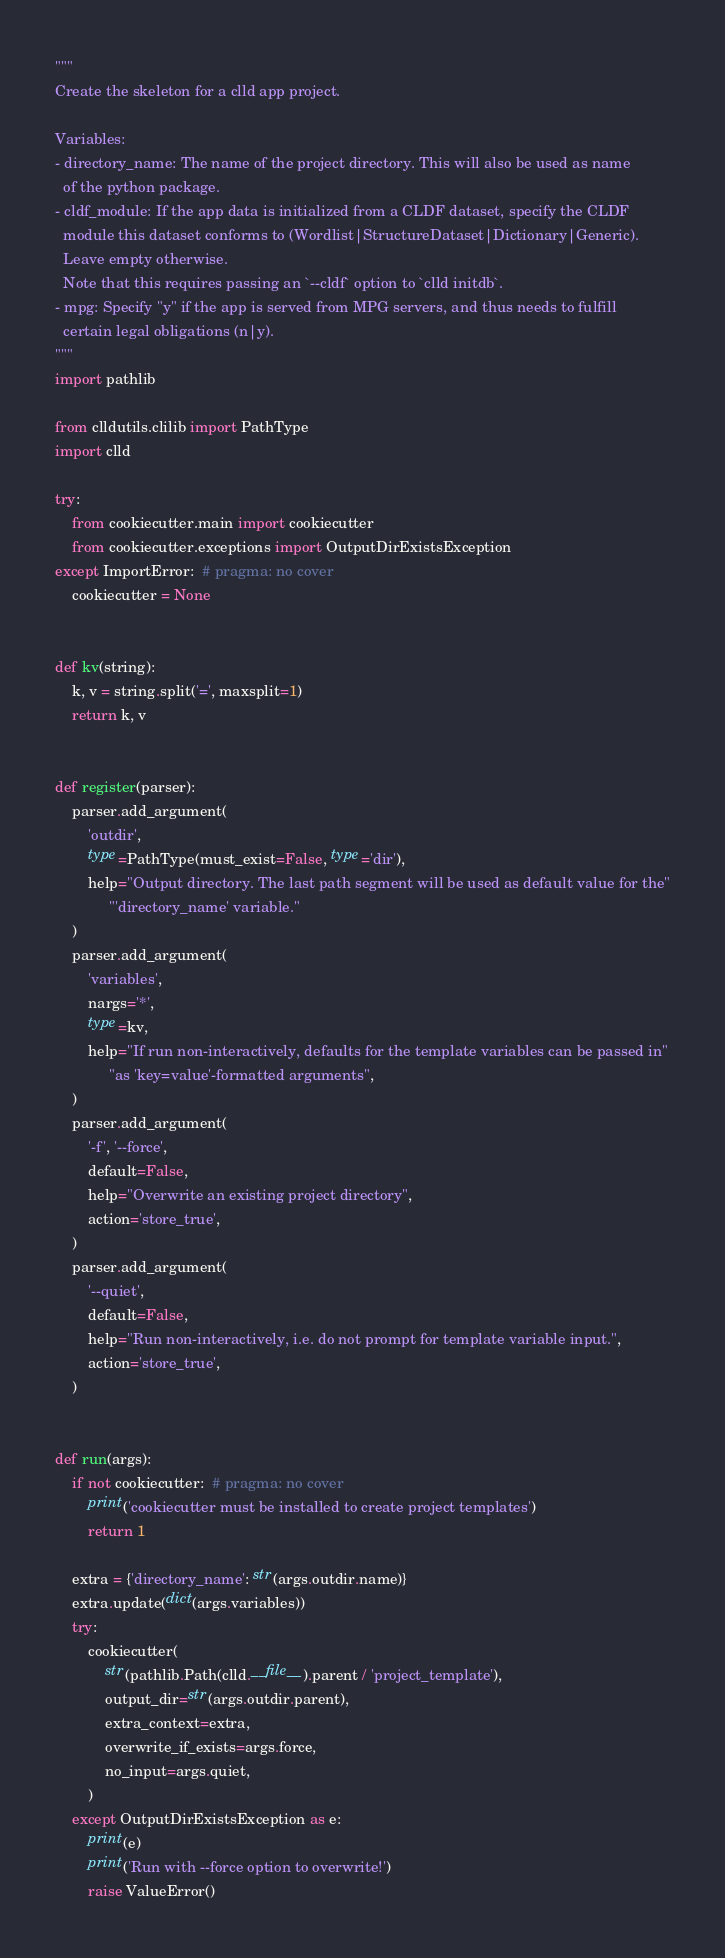Convert code to text. <code><loc_0><loc_0><loc_500><loc_500><_Python_>"""
Create the skeleton for a clld app project.

Variables:
- directory_name: The name of the project directory. This will also be used as name
  of the python package.
- cldf_module: If the app data is initialized from a CLDF dataset, specify the CLDF
  module this dataset conforms to (Wordlist|StructureDataset|Dictionary|Generic).
  Leave empty otherwise.
  Note that this requires passing an `--cldf` option to `clld initdb`.
- mpg: Specify "y" if the app is served from MPG servers, and thus needs to fulfill
  certain legal obligations (n|y).
"""
import pathlib

from clldutils.clilib import PathType
import clld

try:
    from cookiecutter.main import cookiecutter
    from cookiecutter.exceptions import OutputDirExistsException
except ImportError:  # pragma: no cover
    cookiecutter = None


def kv(string):
    k, v = string.split('=', maxsplit=1)
    return k, v


def register(parser):
    parser.add_argument(
        'outdir',
        type=PathType(must_exist=False, type='dir'),
        help="Output directory. The last path segment will be used as default value for the"
             "'directory_name' variable."
    )
    parser.add_argument(
        'variables',
        nargs='*',
        type=kv,
        help="If run non-interactively, defaults for the template variables can be passed in"
             "as 'key=value'-formatted arguments",
    )
    parser.add_argument(
        '-f', '--force',
        default=False,
        help="Overwrite an existing project directory",
        action='store_true',
    )
    parser.add_argument(
        '--quiet',
        default=False,
        help="Run non-interactively, i.e. do not prompt for template variable input.",
        action='store_true',
    )


def run(args):
    if not cookiecutter:  # pragma: no cover
        print('cookiecutter must be installed to create project templates')
        return 1

    extra = {'directory_name': str(args.outdir.name)}
    extra.update(dict(args.variables))
    try:
        cookiecutter(
            str(pathlib.Path(clld.__file__).parent / 'project_template'),
            output_dir=str(args.outdir.parent),
            extra_context=extra,
            overwrite_if_exists=args.force,
            no_input=args.quiet,
        )
    except OutputDirExistsException as e:
        print(e)
        print('Run with --force option to overwrite!')
        raise ValueError()
</code> 